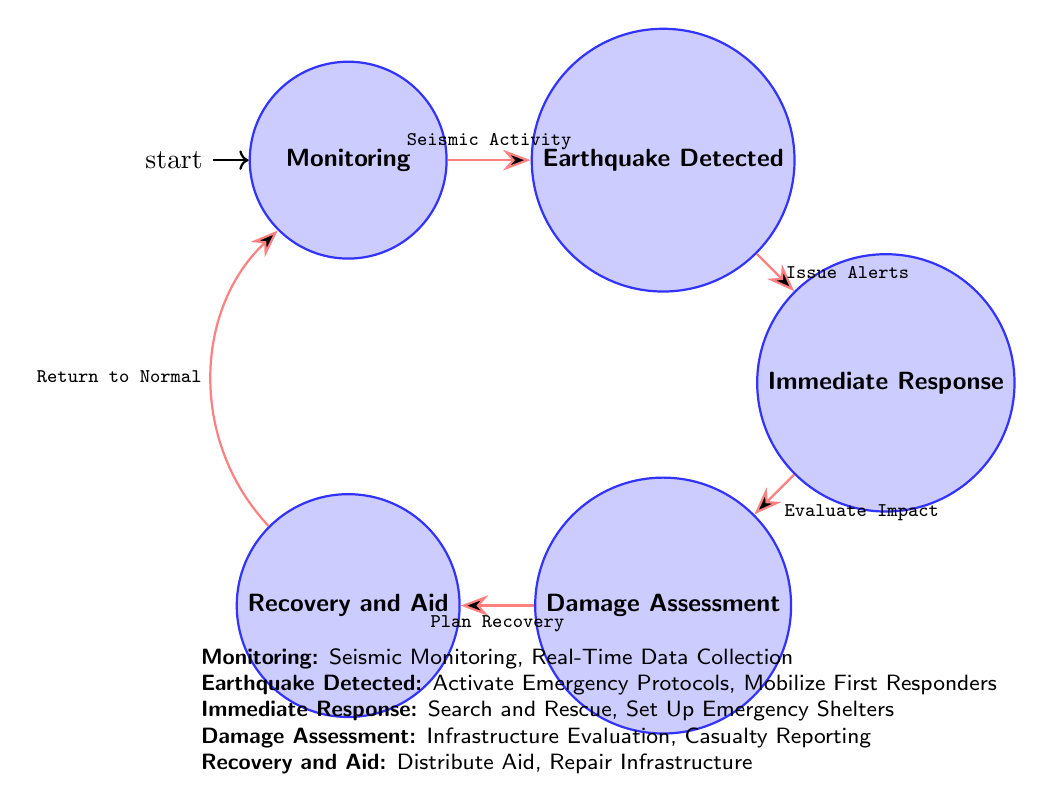What is the initial state in the diagram? The diagram indicates that the initial state is the "Monitoring" state, which is marked as the starting point of the workflow.
Answer: Monitoring How many states are in the diagram? By counting the states indicated in the diagram, there are five distinct states: Monitoring, Earthquake Detected, Immediate Response, Damage Assessment, and Recovery and Aid.
Answer: 5 What actions are taken in the "Immediate Response" state? According to the diagram, the actions performed in the "Immediate Response" state include: Search and Rescue Operations, Set Up Emergency Shelters, and Coordinate with Local Authorities.
Answer: Search and Rescue Operations, Set Up Emergency Shelters, Coordinate with Local Authorities What is the transition from "Damage Assessment" to "Recovery and Aid"? The transition from "Damage Assessment" to "Recovery and Aid" happens through the action labeled "Plan Recovery". This action signifies the process of evaluating and preparing for recovery after damage assessment.
Answer: Plan Recovery Which state leads to issuing alerts? The state that leads to issuing alerts is "Earthquake Detected". This state initiates the alerts as part of the immediate response once an earthquake is confirmed.
Answer: Earthquake Detected What is the last step in the workflow before returning to "Monitoring"? The last step in the workflow before returning to "Monitoring" is "Distribute Aid", which indicates the ongoing efforts to aid recovery after an earthquake event before the workflow starts again.
Answer: Distribute Aid What actions are involved in the "Monitoring" state? The actions involved in the "Monitoring" state include Seismic Monitoring, Real-Time Data Collection, and Analysis by Colorado Geological Survey, which serve to maintain oversight before an earthquake is detected.
Answer: Seismic Monitoring, Real-Time Data Collection, Analysis by Colorado Geological Survey In which state are alerts issued? Alerts are issued in the "Immediate Response" state, as indicated when the transition occurs following the detection of an earthquake.
Answer: Immediate Response 